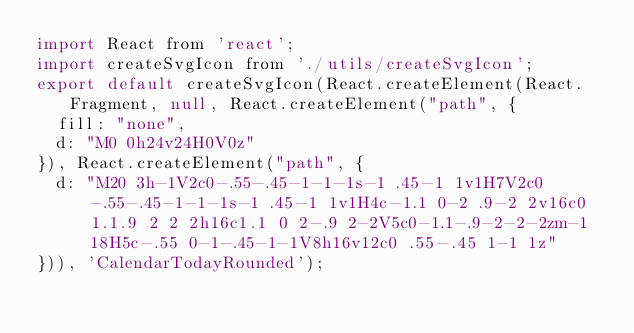<code> <loc_0><loc_0><loc_500><loc_500><_JavaScript_>import React from 'react';
import createSvgIcon from './utils/createSvgIcon';
export default createSvgIcon(React.createElement(React.Fragment, null, React.createElement("path", {
  fill: "none",
  d: "M0 0h24v24H0V0z"
}), React.createElement("path", {
  d: "M20 3h-1V2c0-.55-.45-1-1-1s-1 .45-1 1v1H7V2c0-.55-.45-1-1-1s-1 .45-1 1v1H4c-1.1 0-2 .9-2 2v16c0 1.1.9 2 2 2h16c1.1 0 2-.9 2-2V5c0-1.1-.9-2-2-2zm-1 18H5c-.55 0-1-.45-1-1V8h16v12c0 .55-.45 1-1 1z"
})), 'CalendarTodayRounded');</code> 